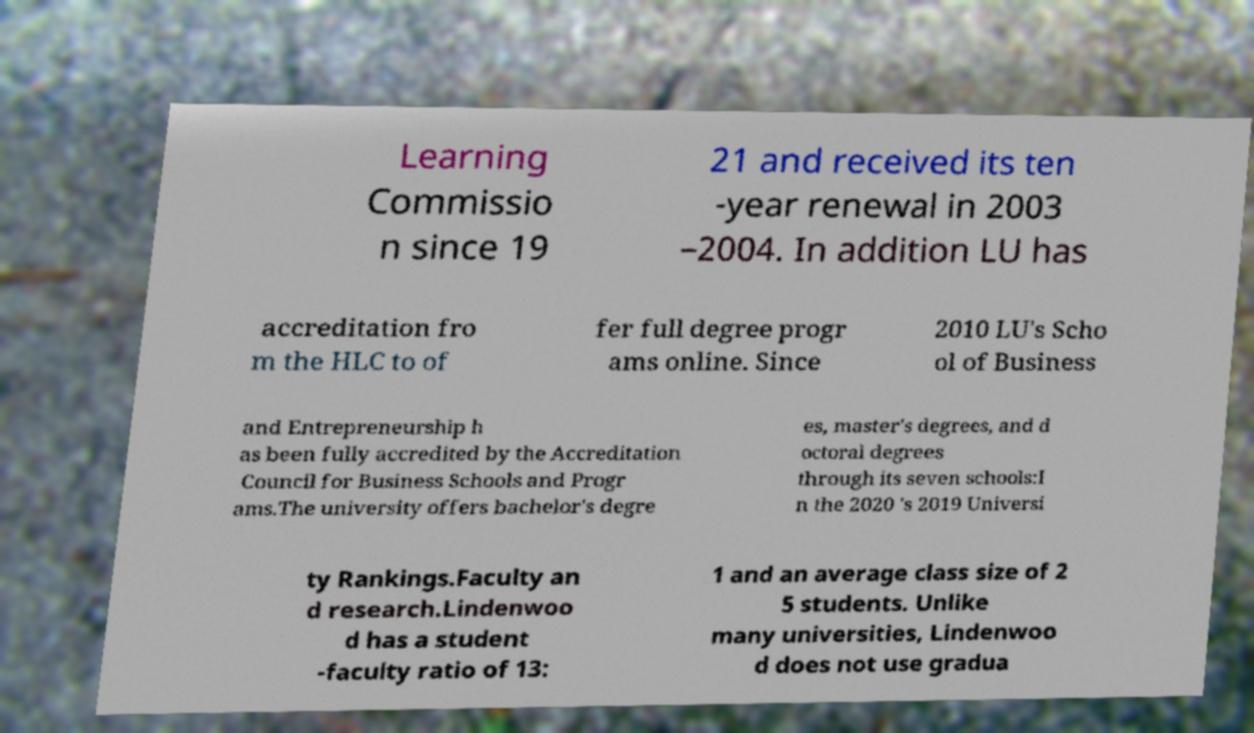Please identify and transcribe the text found in this image. Learning Commissio n since 19 21 and received its ten -year renewal in 2003 –2004. In addition LU has accreditation fro m the HLC to of fer full degree progr ams online. Since 2010 LU's Scho ol of Business and Entrepreneurship h as been fully accredited by the Accreditation Council for Business Schools and Progr ams.The university offers bachelor's degre es, master's degrees, and d octoral degrees through its seven schools:I n the 2020 's 2019 Universi ty Rankings.Faculty an d research.Lindenwoo d has a student -faculty ratio of 13: 1 and an average class size of 2 5 students. Unlike many universities, Lindenwoo d does not use gradua 